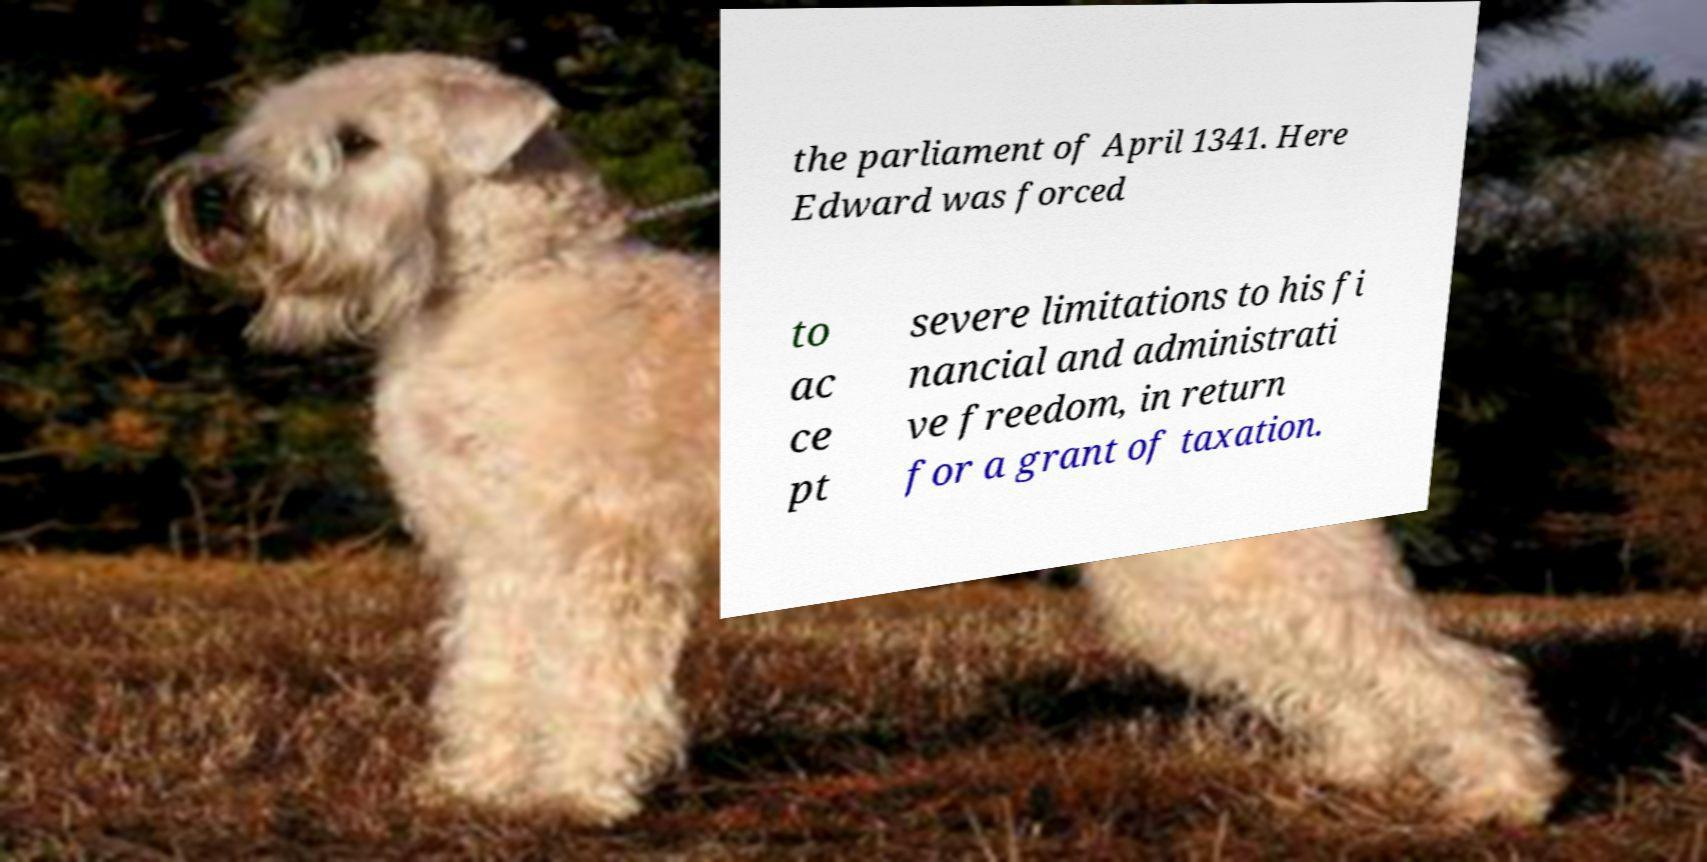There's text embedded in this image that I need extracted. Can you transcribe it verbatim? the parliament of April 1341. Here Edward was forced to ac ce pt severe limitations to his fi nancial and administrati ve freedom, in return for a grant of taxation. 